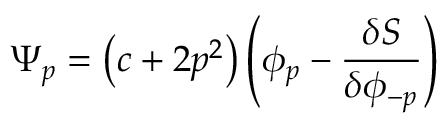<formula> <loc_0><loc_0><loc_500><loc_500>\Psi _ { p } = \left ( c + 2 p ^ { 2 } \right ) \left ( \phi _ { p } - \frac { \delta S } { \delta \phi _ { - p } } \right )</formula> 